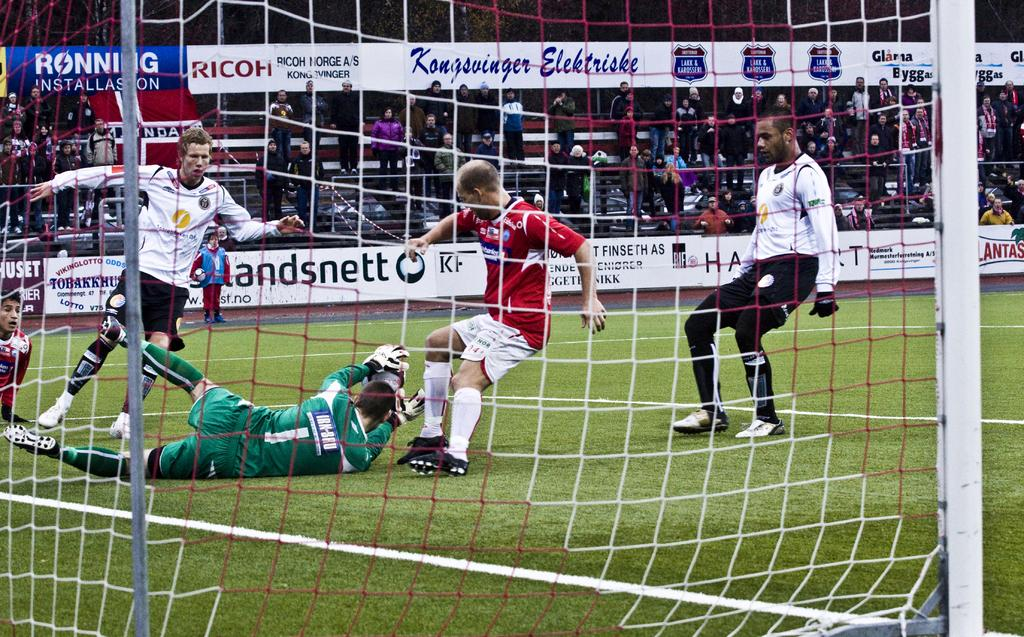<image>
Relay a brief, clear account of the picture shown. View from behind a soccer goal as number one dives for the ball. 